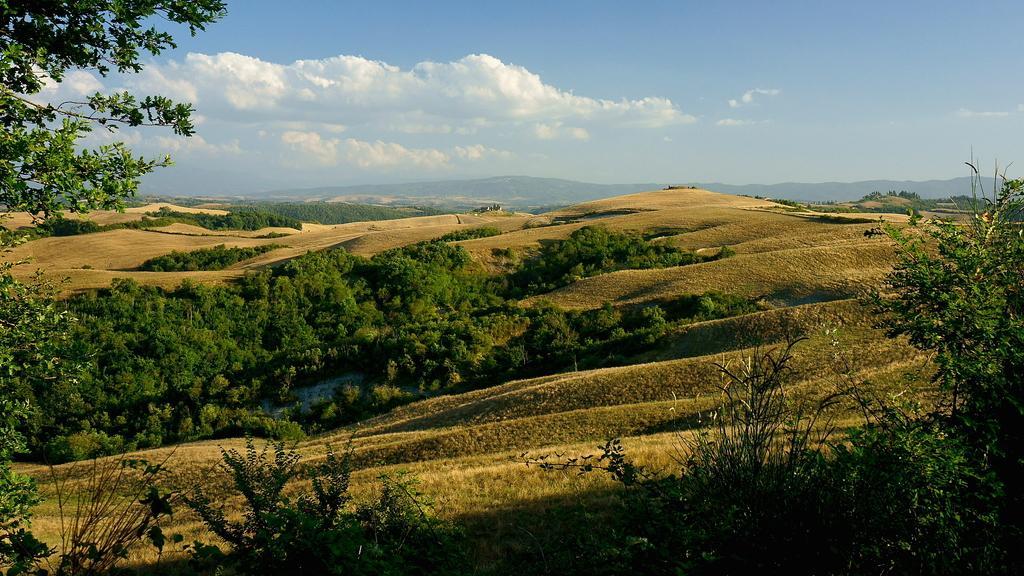How would you summarize this image in a sentence or two? In this picture there is greenery, it seems like grassland in the foreground. There are mountains and sky in the background area. 